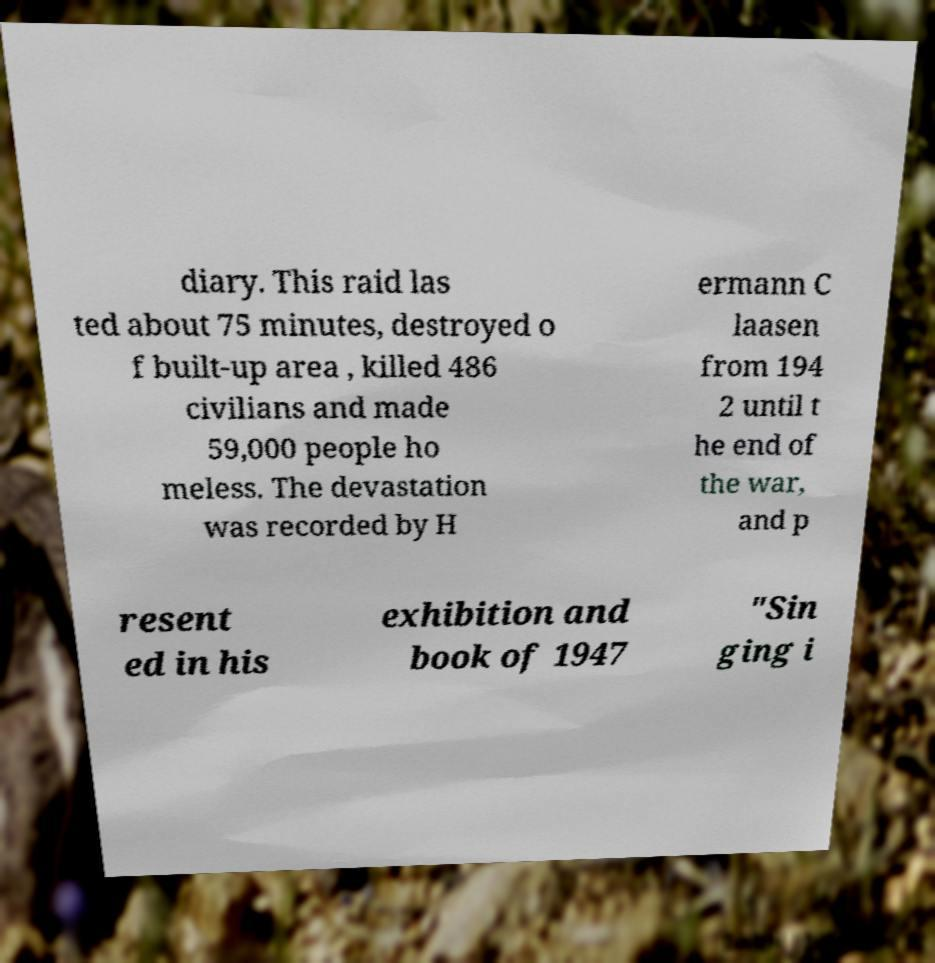Can you read and provide the text displayed in the image?This photo seems to have some interesting text. Can you extract and type it out for me? diary. This raid las ted about 75 minutes, destroyed o f built-up area , killed 486 civilians and made 59,000 people ho meless. The devastation was recorded by H ermann C laasen from 194 2 until t he end of the war, and p resent ed in his exhibition and book of 1947 "Sin ging i 